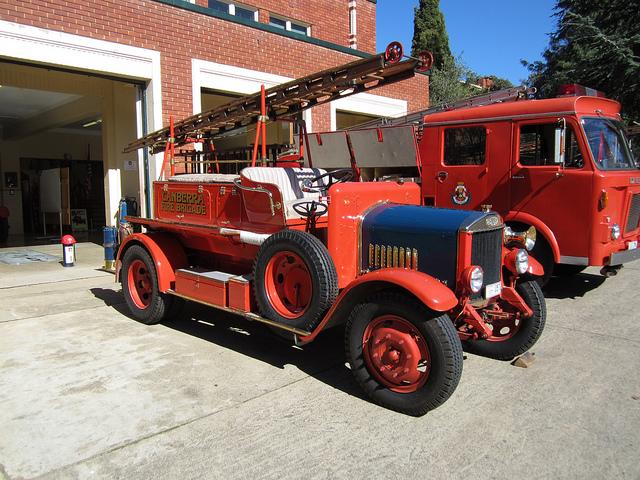What is the main color of the vehicle?
Write a very short answer. Red. How many wheels does the vehicle have on the ground?
Give a very brief answer. 4. Is it grassy?
Concise answer only. No. Are these vintage fire trucks?
Write a very short answer. Yes. 